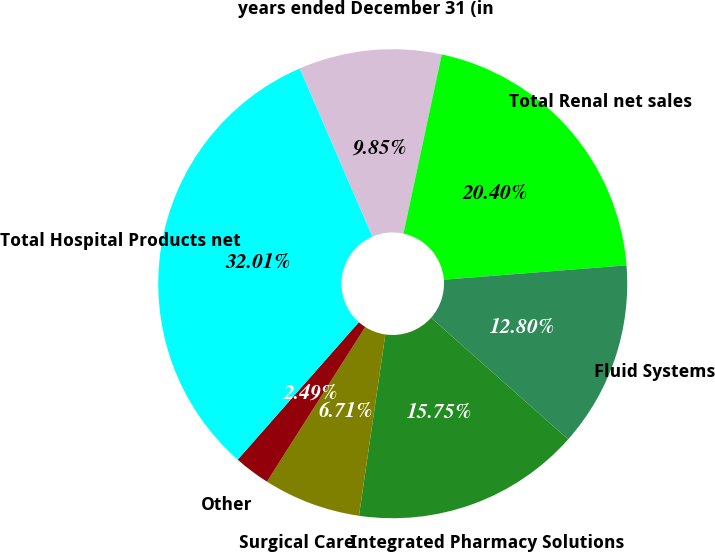Convert chart to OTSL. <chart><loc_0><loc_0><loc_500><loc_500><pie_chart><fcel>years ended December 31 (in<fcel>Total Renal net sales<fcel>Fluid Systems<fcel>Integrated Pharmacy Solutions<fcel>Surgical Care<fcel>Other<fcel>Total Hospital Products net<nl><fcel>9.85%<fcel>20.4%<fcel>12.8%<fcel>15.75%<fcel>6.71%<fcel>2.49%<fcel>32.01%<nl></chart> 